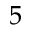Convert formula to latex. <formula><loc_0><loc_0><loc_500><loc_500>5</formula> 